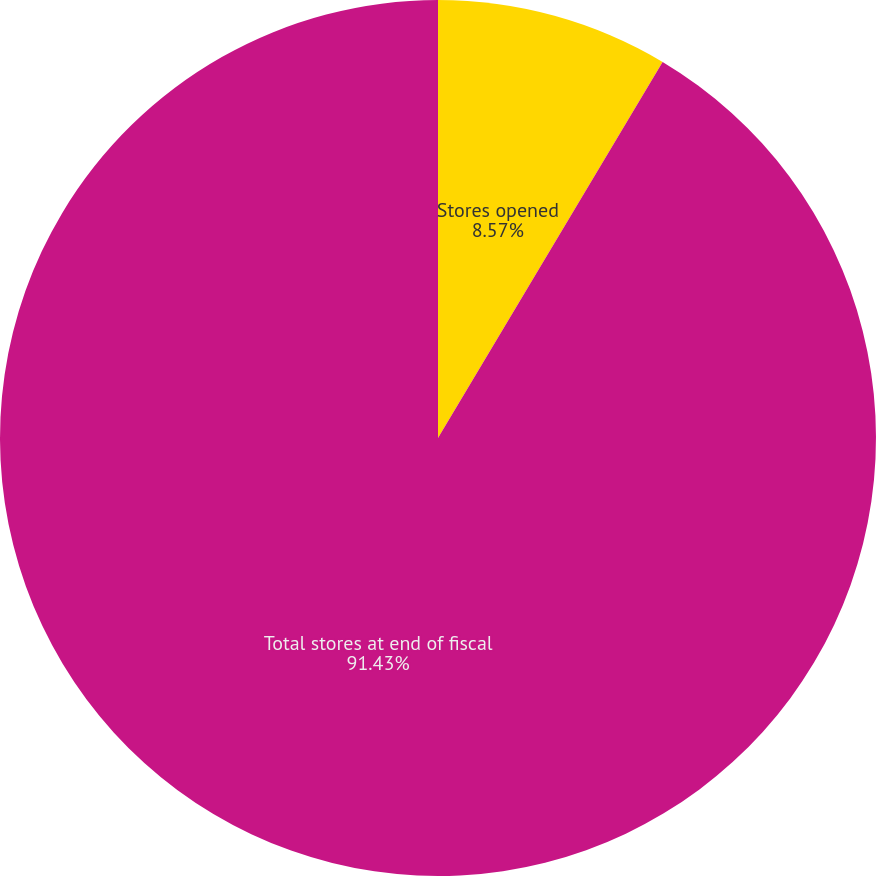Convert chart. <chart><loc_0><loc_0><loc_500><loc_500><pie_chart><fcel>Stores opened<fcel>Total stores at end of fiscal<nl><fcel>8.57%<fcel>91.43%<nl></chart> 